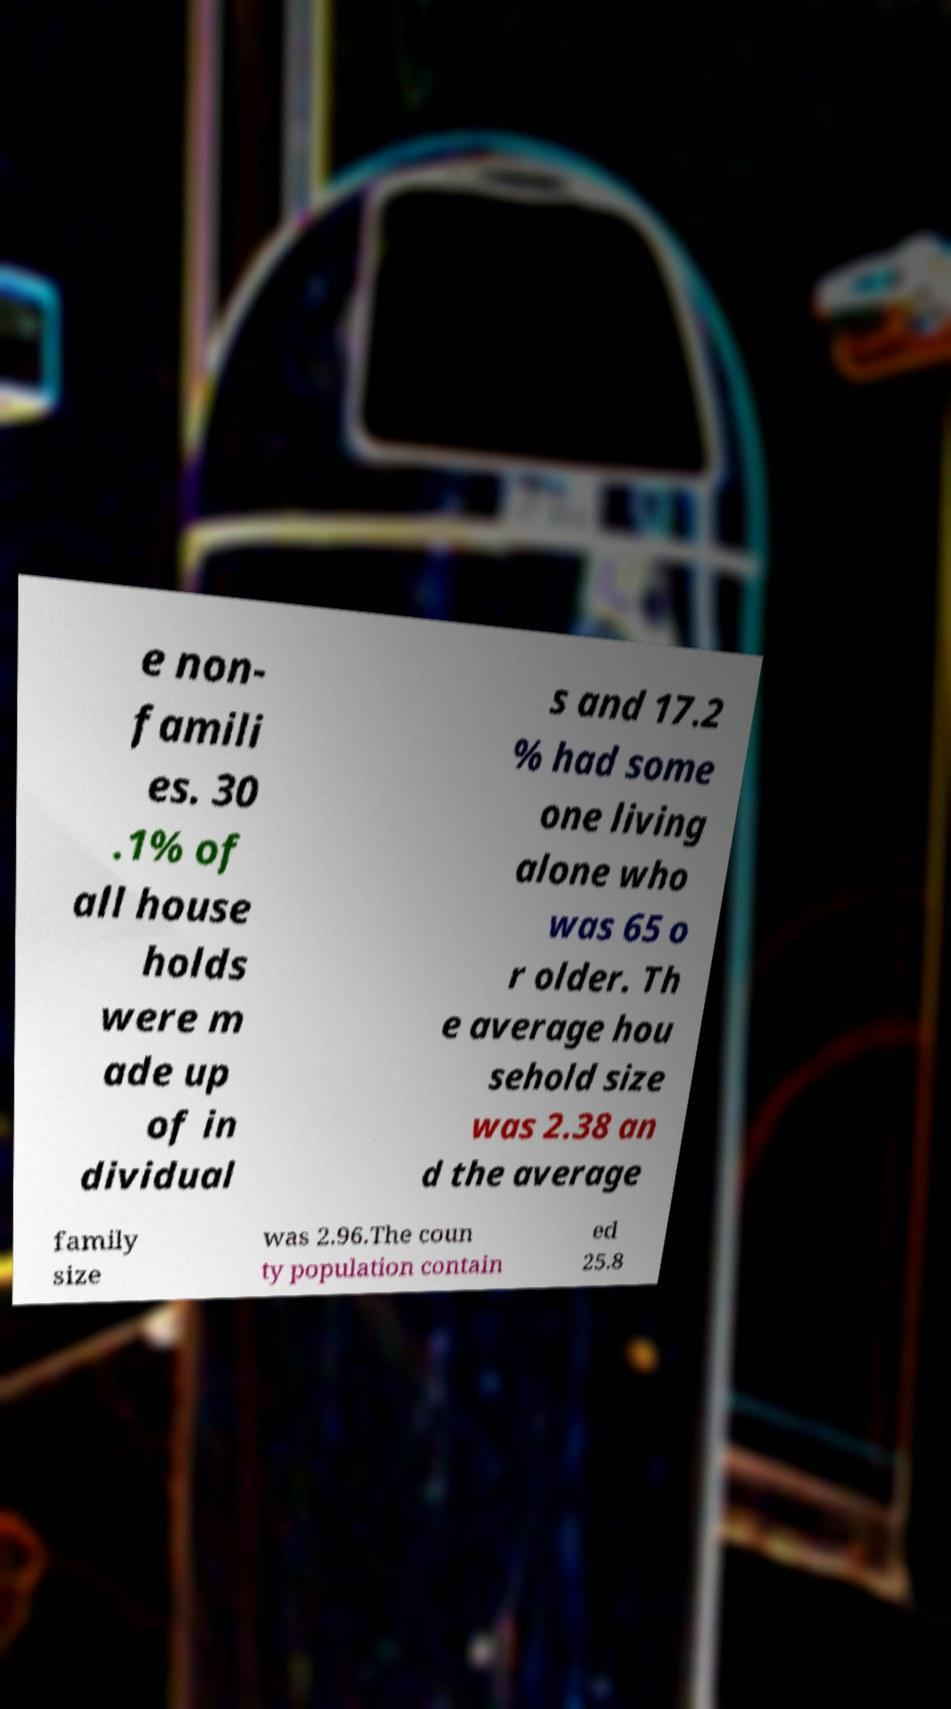Please identify and transcribe the text found in this image. e non- famili es. 30 .1% of all house holds were m ade up of in dividual s and 17.2 % had some one living alone who was 65 o r older. Th e average hou sehold size was 2.38 an d the average family size was 2.96.The coun ty population contain ed 25.8 